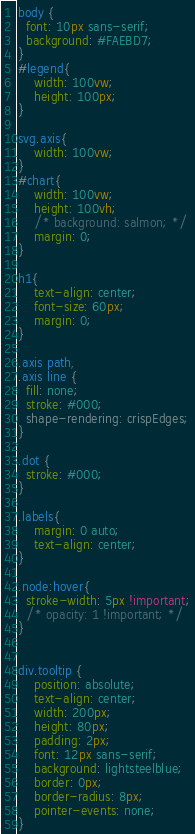Convert code to text. <code><loc_0><loc_0><loc_500><loc_500><_CSS_>body {
  font: 10px sans-serif;
  background: #FAEBD7;
}
#legend{
    width: 100vw;
    height: 100px;
}

svg.axis{
    width: 100vw;
}
#chart{
    width: 100vw;
    height: 100vh;
    /* background: salmon; */
    margin: 0;
}

h1{
    text-align: center;
    font-size: 60px;
    margin: 0;
}

.axis path,
.axis line {
  fill: none;
  stroke: #000;
  shape-rendering: crispEdges;
}

.dot {
  stroke: #000;
}

.labels{
    margin: 0 auto;
    text-align: center;
}

.node:hover{
  stroke-width: 5px !important;
  /* opacity: 1 !important; */
}


div.tooltip {
    position: absolute;
    text-align: center;
    width: 200px;
    height: 80px;
    padding: 2px;
    font: 12px sans-serif;
    background: lightsteelblue;
    border: 0px;
    border-radius: 8px;
    pointer-events: none;
}
</code> 